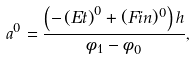<formula> <loc_0><loc_0><loc_500><loc_500>a ^ { 0 } = \frac { \left ( - \left ( E t \right ) ^ { 0 } + ( F i n ) ^ { 0 } \right ) h } { \phi _ { 1 } - \phi _ { 0 } } ,</formula> 